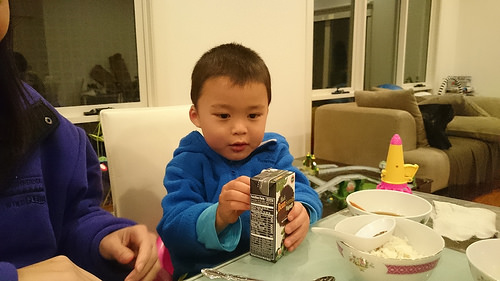<image>
Is the food next to the spoon? Yes. The food is positioned adjacent to the spoon, located nearby in the same general area. 